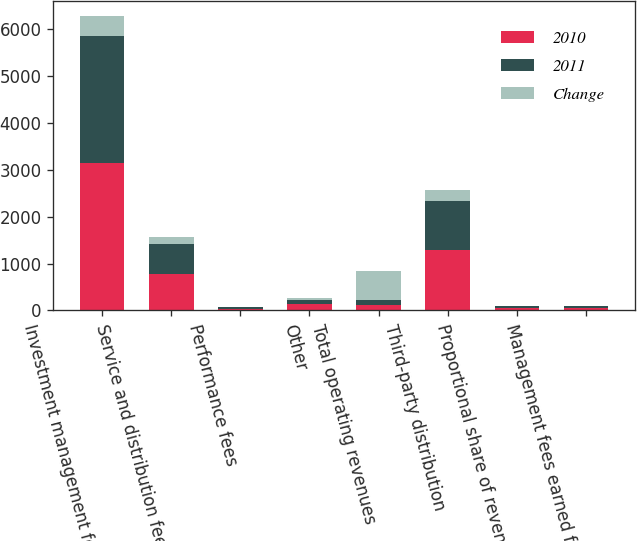Convert chart. <chart><loc_0><loc_0><loc_500><loc_500><stacked_bar_chart><ecel><fcel>Investment management fees<fcel>Service and distribution fees<fcel>Performance fees<fcel>Other<fcel>Total operating revenues<fcel>Third-party distribution<fcel>Proportional share of revenues<fcel>Management fees earned from<nl><fcel>2010<fcel>3138.5<fcel>780.3<fcel>37.9<fcel>135.5<fcel>115<fcel>1282.5<fcel>41.4<fcel>46.8<nl><fcel>2011<fcel>2720.9<fcel>645.5<fcel>26.1<fcel>95.2<fcel>115<fcel>1053.8<fcel>42.2<fcel>45.3<nl><fcel>Change<fcel>417.6<fcel>134.8<fcel>11.8<fcel>40.3<fcel>604.5<fcel>228.7<fcel>0.8<fcel>1.5<nl></chart> 